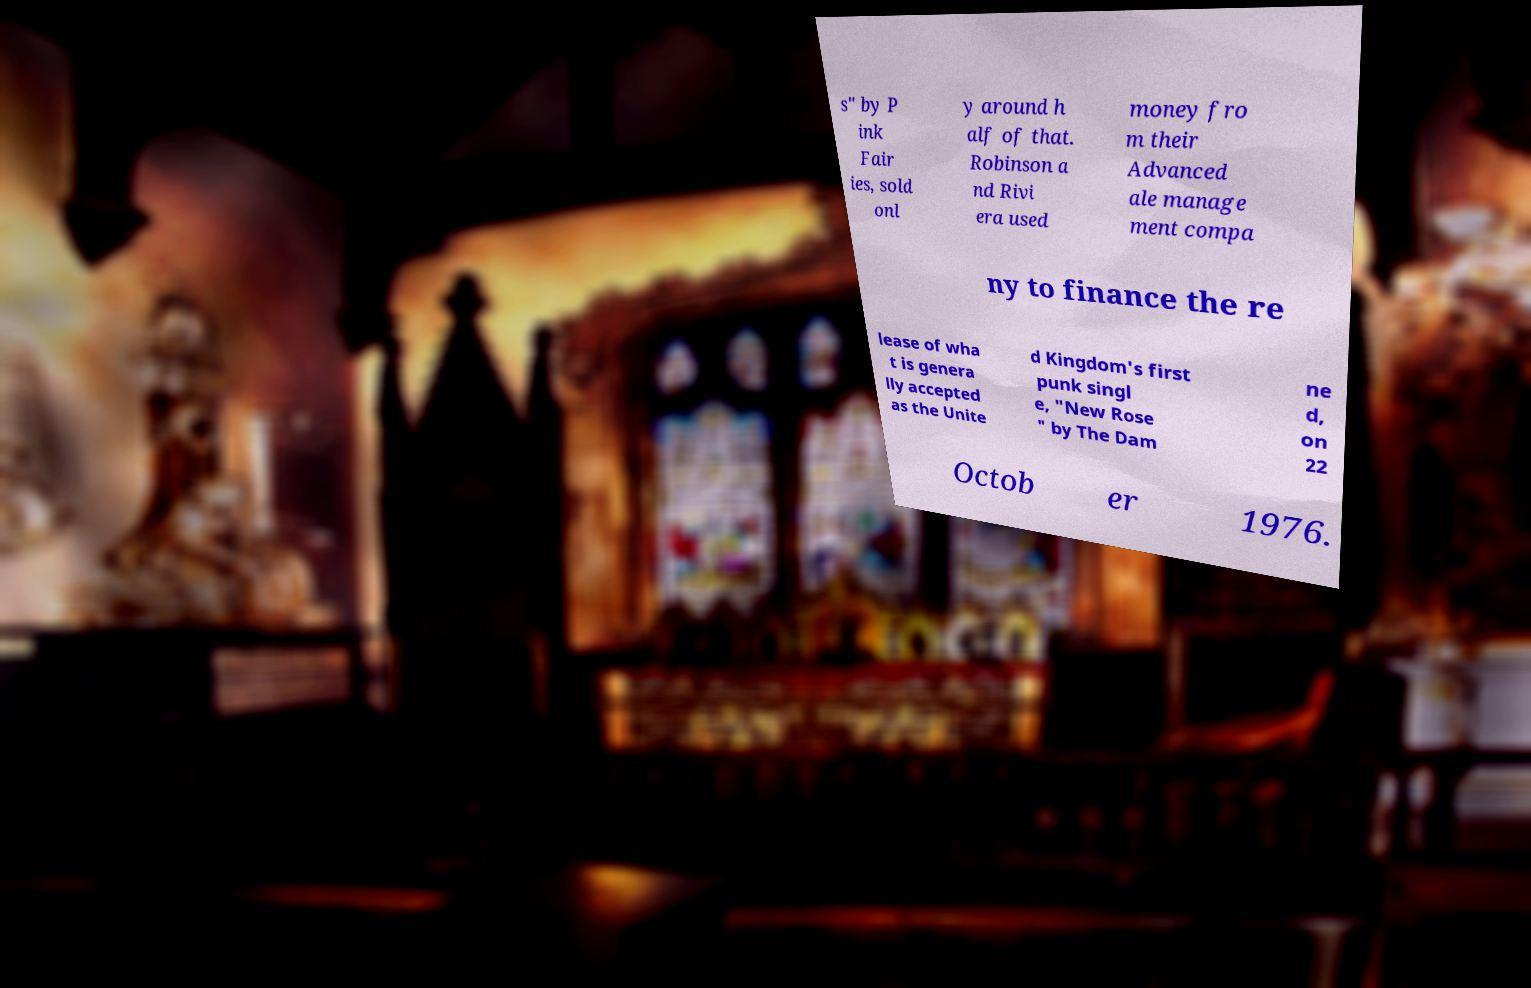What messages or text are displayed in this image? I need them in a readable, typed format. s" by P ink Fair ies, sold onl y around h alf of that. Robinson a nd Rivi era used money fro m their Advanced ale manage ment compa ny to finance the re lease of wha t is genera lly accepted as the Unite d Kingdom's first punk singl e, "New Rose " by The Dam ne d, on 22 Octob er 1976. 